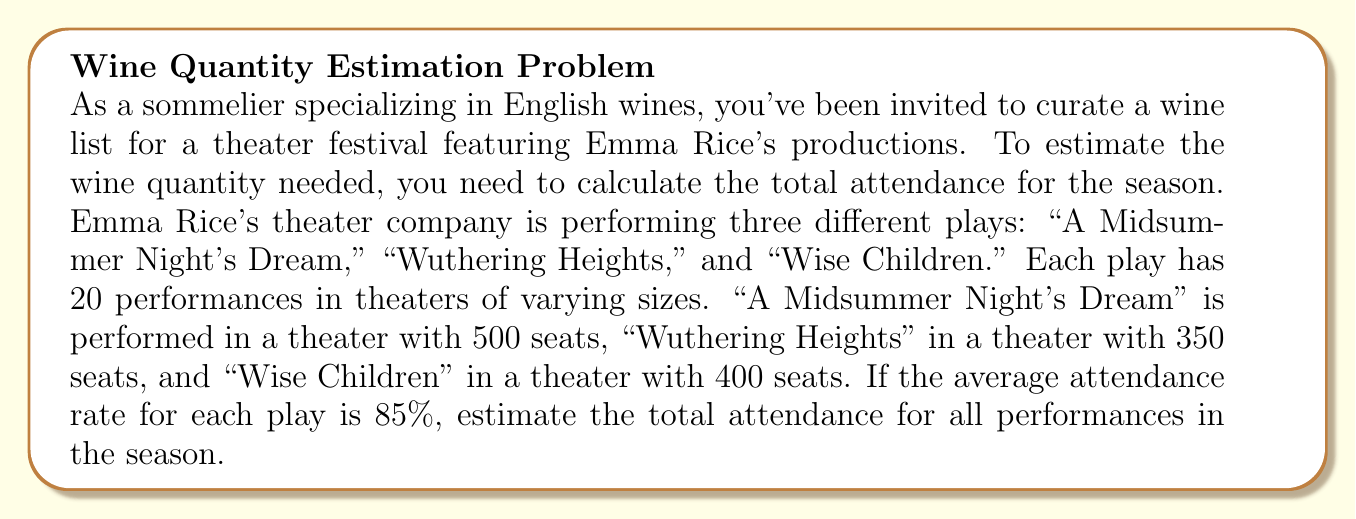Show me your answer to this math problem. To solve this problem, we'll follow these steps:

1. Calculate the maximum capacity for each play:
   - "A Midsummer Night's Dream": $500 \text{ seats} \times 20 \text{ performances} = 10,000 \text{ seats}$
   - "Wuthering Heights": $350 \text{ seats} \times 20 \text{ performances} = 7,000 \text{ seats}$
   - "Wise Children": $400 \text{ seats} \times 20 \text{ performances} = 8,000 \text{ seats}$

2. Calculate the total maximum capacity:
   $\text{Total max capacity} = 10,000 + 7,000 + 8,000 = 25,000 \text{ seats}$

3. Apply the average attendance rate:
   $\text{Estimated total attendance} = \text{Total max capacity} \times \text{Average attendance rate}$
   $\text{Estimated total attendance} = 25,000 \times 0.85 = 21,250$

Therefore, the estimated total attendance for all performances in the season is 21,250 people.
Answer: The estimated total attendance for all Emma Rice theater productions over the season is 21,250 people. 